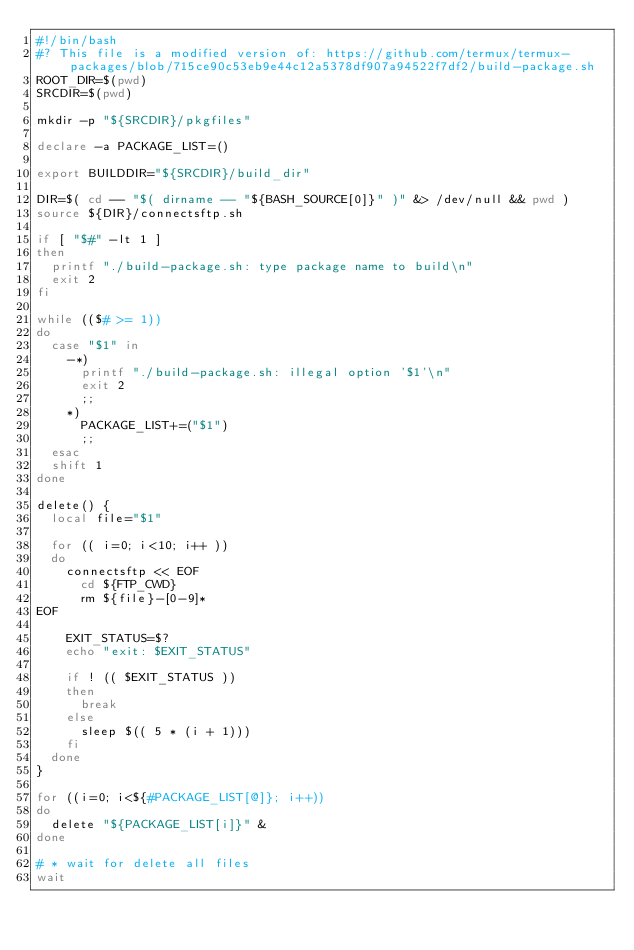Convert code to text. <code><loc_0><loc_0><loc_500><loc_500><_Bash_>#!/bin/bash
#? This file is a modified version of: https://github.com/termux/termux-packages/blob/715ce90c53eb9e44c12a5378df907a94522f7df2/build-package.sh
ROOT_DIR=$(pwd)
SRCDIR=$(pwd)

mkdir -p "${SRCDIR}/pkgfiles"

declare -a PACKAGE_LIST=()

export BUILDDIR="${SRCDIR}/build_dir"

DIR=$( cd -- "$( dirname -- "${BASH_SOURCE[0]}" )" &> /dev/null && pwd )
source ${DIR}/connectsftp.sh

if [ "$#" -lt 1 ]
then
  printf "./build-package.sh: type package name to build\n"
  exit 2
fi

while (($# >= 1))
do
  case "$1" in
    -*)
      printf "./build-package.sh: illegal option '$1'\n"
      exit 2
      ;;
    *)
      PACKAGE_LIST+=("$1")
      ;;
  esac
  shift 1
done

delete() {
  local file="$1"

  for (( i=0; i<10; i++ ))
  do
    connectsftp << EOF
      cd ${FTP_CWD}
      rm ${file}-[0-9]*
EOF

    EXIT_STATUS=$?
    echo "exit: $EXIT_STATUS"

    if ! (( $EXIT_STATUS ))
    then
      break
    else
      sleep $(( 5 * (i + 1)))
    fi
  done
}

for ((i=0; i<${#PACKAGE_LIST[@]}; i++))
do
  delete "${PACKAGE_LIST[i]}" &
done

# * wait for delete all files
wait
</code> 